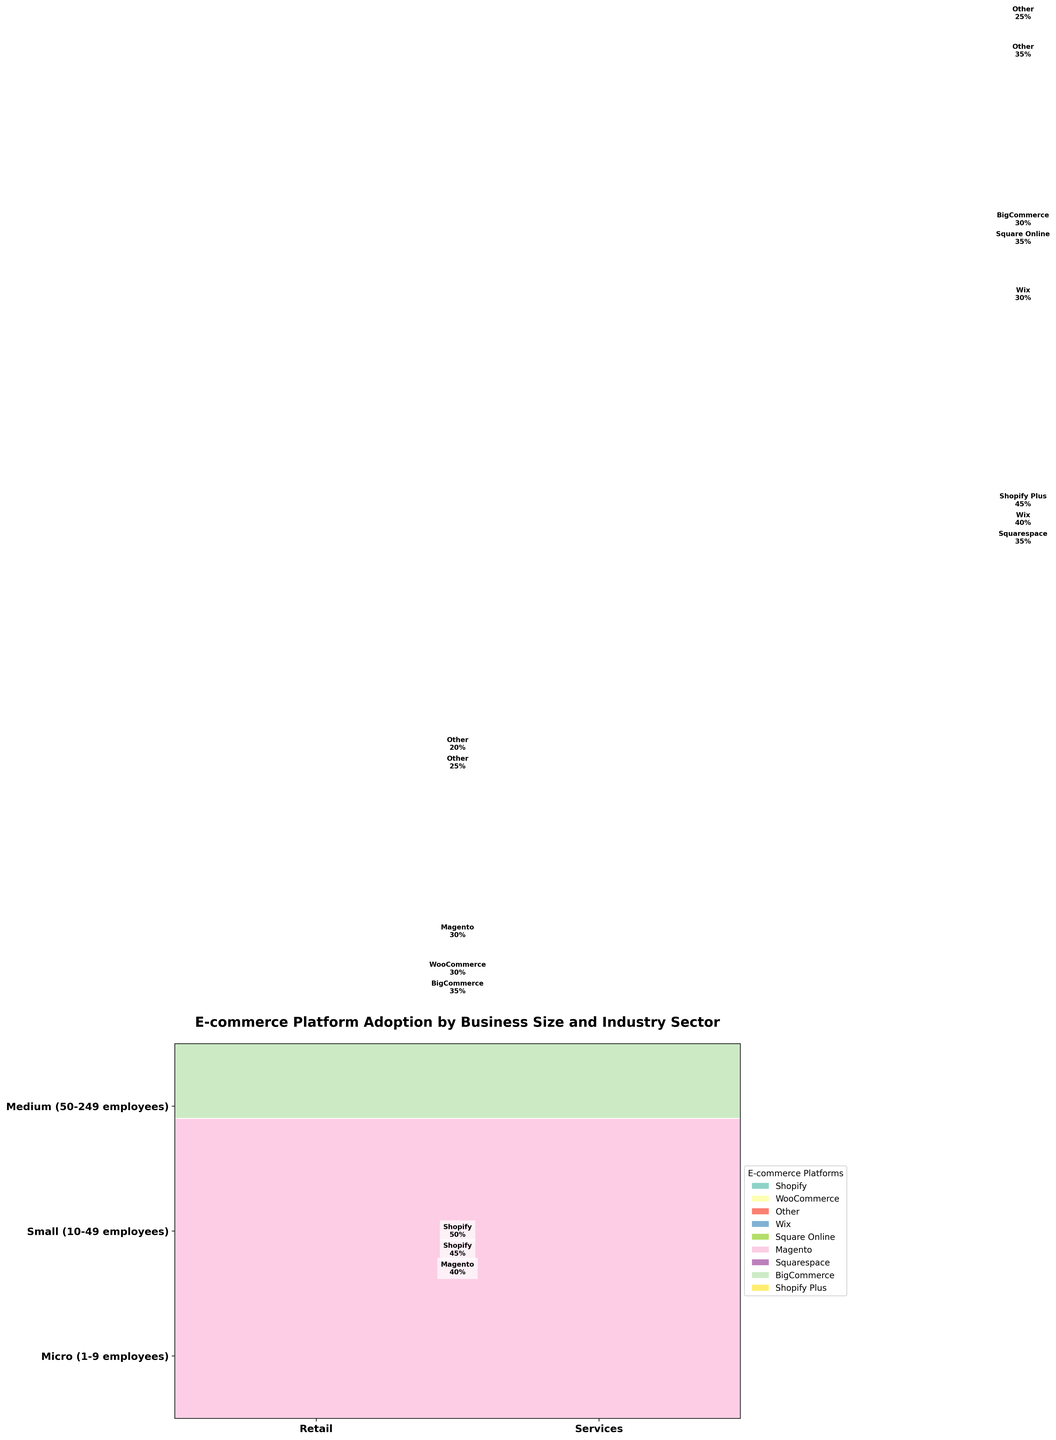How are e-commerce platforms distinguished in the figure? E-commerce platforms are distinguished by different colors assigned to each platform in the plot. Each platform has a unique color represented in the legend to the right of the plot.
Answer: Different colors Which business size in the retail sector has the highest adoption rate for Shopify? To find this, look at the adoption rate values within each business size in the retail sector. Micro-sized businesses have a 45% adoption rate for Shopify, small-sized have a 50%, and medium-sized do not have Shopify listed. So, the small-sized businesses in the retail sector have the highest adoption rate for Shopify.
Answer: Small-sized businesses What's the total adoption rate for e-commerce platforms in medium-sized service businesses? Sum the adoption rates for all e-commerce platforms within medium-sized service businesses. The platforms are Shopify Plus (45%), BigCommerce (30%), and Other (25%). Adding them together: 45 + 30 + 25 = 100.
Answer: 100% Which platform has the lowest adoption rate among micro-sized retail businesses? In the micro-sized retail businesses, the platforms are Shopify (45%), WooCommerce (30%), and Other (25%). The platform 'Other' has the lowest adoption rate of 25%.
Answer: Other How do the adoption rates of Wix compare between micro-sized and small-sized service businesses? For this, compare the adoption rates of Wix in both micro-sized and small-sized service businesses. Micro-sized service businesses have a 40% adoption rate for Wix, while small-sized service businesses have a 30% adoption rate. Thus, Wix has a higher adoption rate in micro-sized service businesses compared to small-sized ones.
Answer: Higher in micro-sized What is the total adoption rate for the Square Online platform? Locate the Square Online platform in the figure, which appears only in micro-sized service businesses with an adoption rate of 35%. Since it is only mentioned once, the total adoption rate is just 35%.
Answer: 35% Which industry sector shows a more diverse range of e-commerce platform usage in medium-sized businesses? Look at the range of different platforms used in the medium-sized retail and service sectors. The retail sector has Magento (40%), BigCommerce (35%), and Other (25%), while the service sector has Shopify Plus (45%), BigCommerce (30%), and Other (25%). Both sectors have three platforms, but examining the adoption rates shows a broader spread in the retail sector.
Answer: Retail sector 